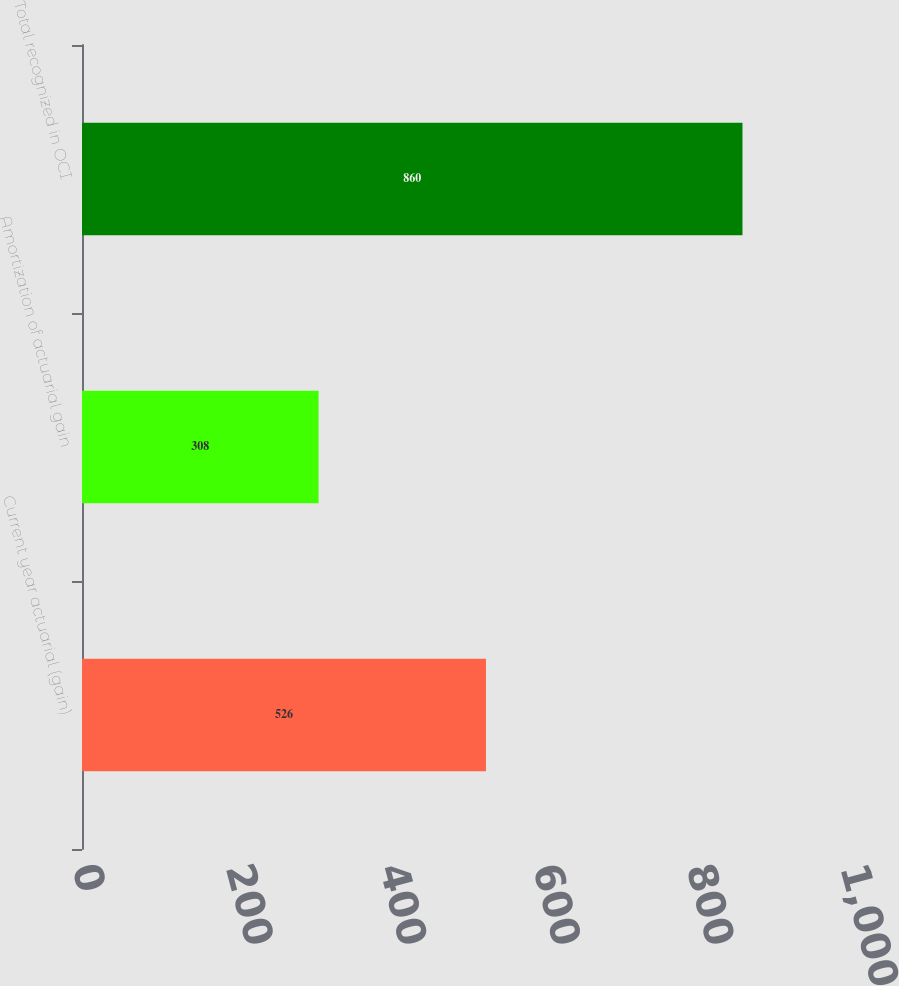Convert chart to OTSL. <chart><loc_0><loc_0><loc_500><loc_500><bar_chart><fcel>Current year actuarial (gain)<fcel>Amortization of actuarial gain<fcel>Total recognized in OCI<nl><fcel>526<fcel>308<fcel>860<nl></chart> 